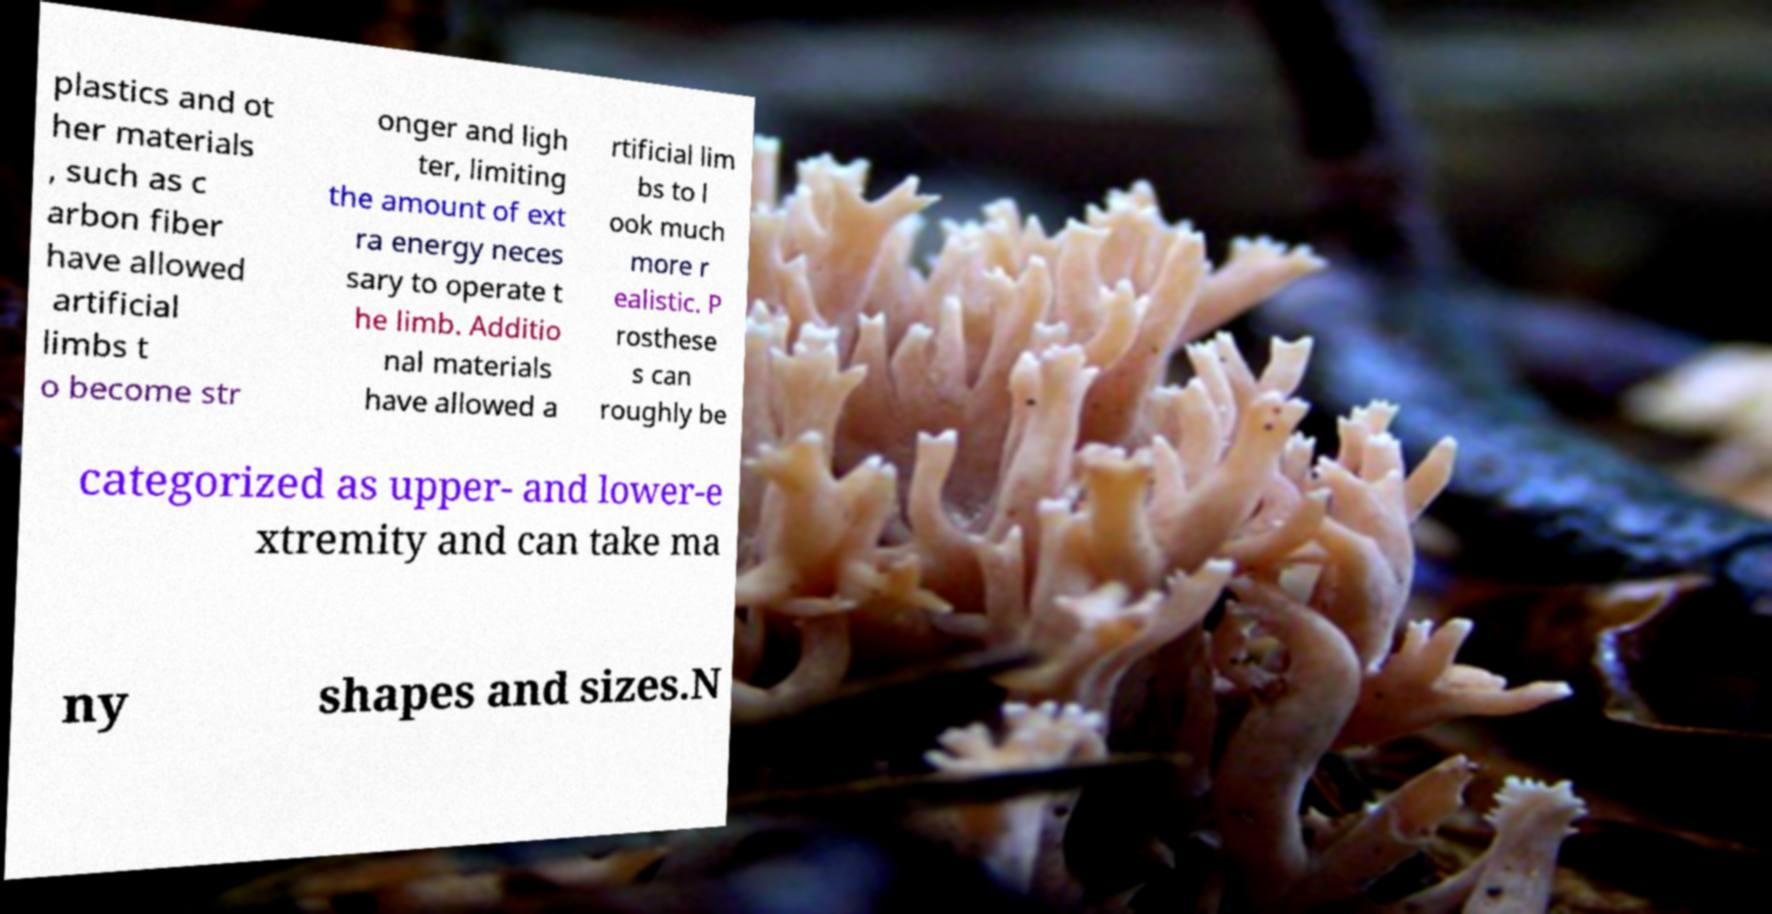Can you accurately transcribe the text from the provided image for me? plastics and ot her materials , such as c arbon fiber have allowed artificial limbs t o become str onger and ligh ter, limiting the amount of ext ra energy neces sary to operate t he limb. Additio nal materials have allowed a rtificial lim bs to l ook much more r ealistic. P rosthese s can roughly be categorized as upper- and lower-e xtremity and can take ma ny shapes and sizes.N 